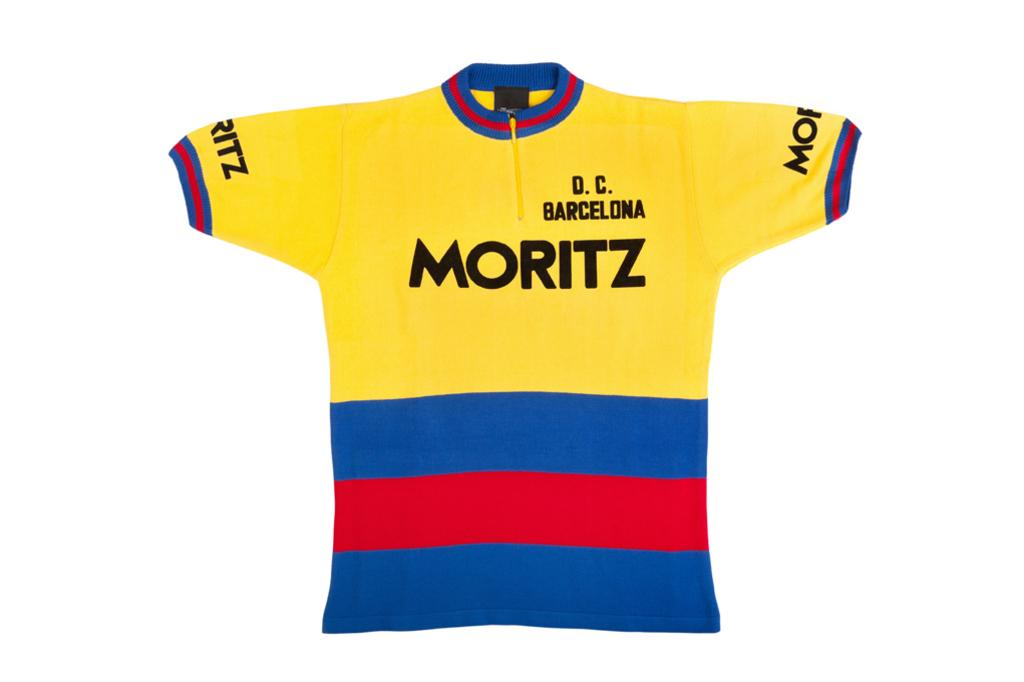Provide a one-sentence caption for the provided image. multi-color jersey for d.c. barcelona with name moritz on it. 